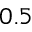Convert formula to latex. <formula><loc_0><loc_0><loc_500><loc_500>0 . 5</formula> 